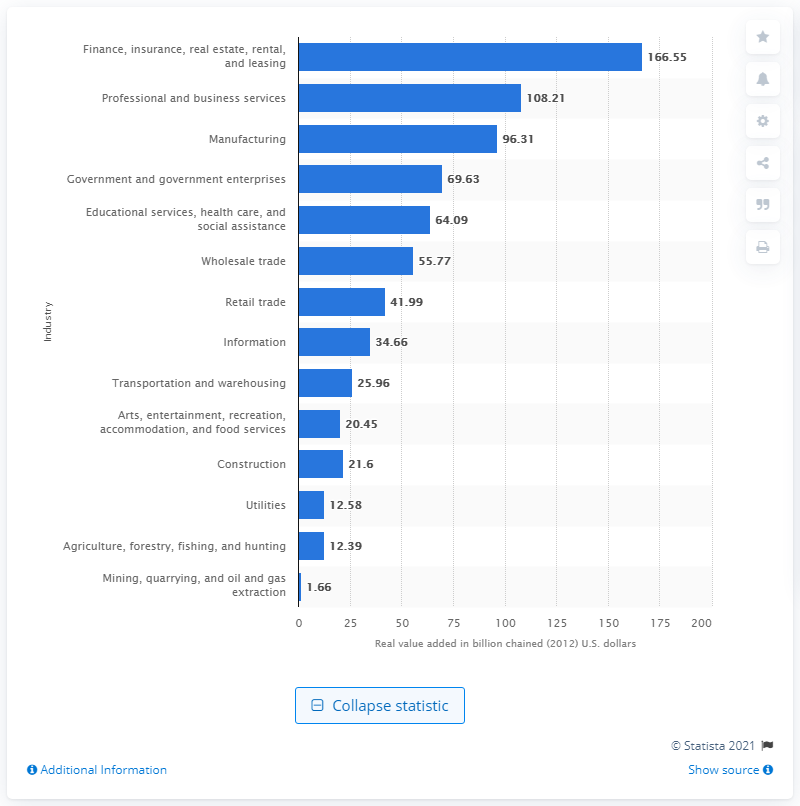Identify some key points in this picture. In 2012, the mining industry contributed 1.66 billion dollars to the state's Gross Domestic Product. 